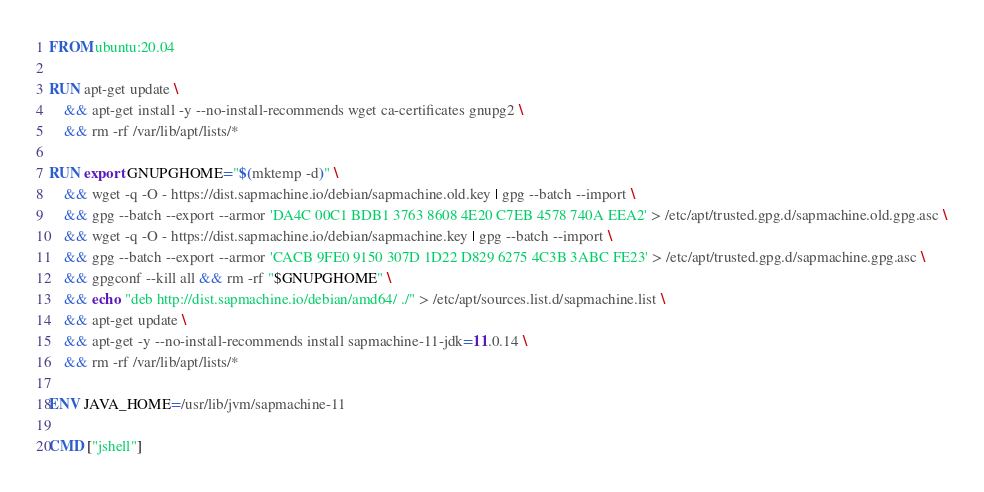Convert code to text. <code><loc_0><loc_0><loc_500><loc_500><_Dockerfile_>
FROM ubuntu:20.04

RUN apt-get update \
    && apt-get install -y --no-install-recommends wget ca-certificates gnupg2 \
    && rm -rf /var/lib/apt/lists/*

RUN export GNUPGHOME="$(mktemp -d)" \
    && wget -q -O - https://dist.sapmachine.io/debian/sapmachine.old.key | gpg --batch --import \
    && gpg --batch --export --armor 'DA4C 00C1 BDB1 3763 8608 4E20 C7EB 4578 740A EEA2' > /etc/apt/trusted.gpg.d/sapmachine.old.gpg.asc \
    && wget -q -O - https://dist.sapmachine.io/debian/sapmachine.key | gpg --batch --import \
    && gpg --batch --export --armor 'CACB 9FE0 9150 307D 1D22 D829 6275 4C3B 3ABC FE23' > /etc/apt/trusted.gpg.d/sapmachine.gpg.asc \
    && gpgconf --kill all && rm -rf "$GNUPGHOME" \
    && echo "deb http://dist.sapmachine.io/debian/amd64/ ./" > /etc/apt/sources.list.d/sapmachine.list \
    && apt-get update \
    && apt-get -y --no-install-recommends install sapmachine-11-jdk=11.0.14 \
    && rm -rf /var/lib/apt/lists/*

ENV JAVA_HOME=/usr/lib/jvm/sapmachine-11

CMD ["jshell"]
</code> 